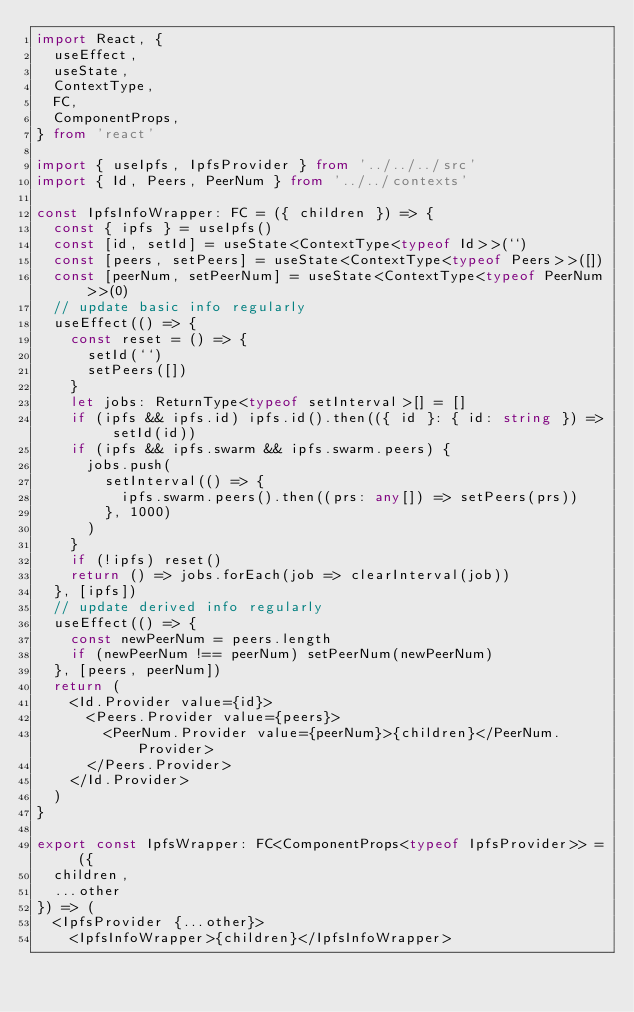Convert code to text. <code><loc_0><loc_0><loc_500><loc_500><_TypeScript_>import React, {
  useEffect,
  useState,
  ContextType,
  FC,
  ComponentProps,
} from 'react'

import { useIpfs, IpfsProvider } from '../../../src'
import { Id, Peers, PeerNum } from '../../contexts'

const IpfsInfoWrapper: FC = ({ children }) => {
  const { ipfs } = useIpfs()
  const [id, setId] = useState<ContextType<typeof Id>>(``)
  const [peers, setPeers] = useState<ContextType<typeof Peers>>([])
  const [peerNum, setPeerNum] = useState<ContextType<typeof PeerNum>>(0)
  // update basic info regularly
  useEffect(() => {
    const reset = () => {
      setId(``)
      setPeers([])
    }
    let jobs: ReturnType<typeof setInterval>[] = []
    if (ipfs && ipfs.id) ipfs.id().then(({ id }: { id: string }) => setId(id))
    if (ipfs && ipfs.swarm && ipfs.swarm.peers) {
      jobs.push(
        setInterval(() => {
          ipfs.swarm.peers().then((prs: any[]) => setPeers(prs))
        }, 1000)
      )
    }
    if (!ipfs) reset()
    return () => jobs.forEach(job => clearInterval(job))
  }, [ipfs])
  // update derived info regularly
  useEffect(() => {
    const newPeerNum = peers.length
    if (newPeerNum !== peerNum) setPeerNum(newPeerNum)
  }, [peers, peerNum])
  return (
    <Id.Provider value={id}>
      <Peers.Provider value={peers}>
        <PeerNum.Provider value={peerNum}>{children}</PeerNum.Provider>
      </Peers.Provider>
    </Id.Provider>
  )
}

export const IpfsWrapper: FC<ComponentProps<typeof IpfsProvider>> = ({
  children,
  ...other
}) => (
  <IpfsProvider {...other}>
    <IpfsInfoWrapper>{children}</IpfsInfoWrapper></code> 